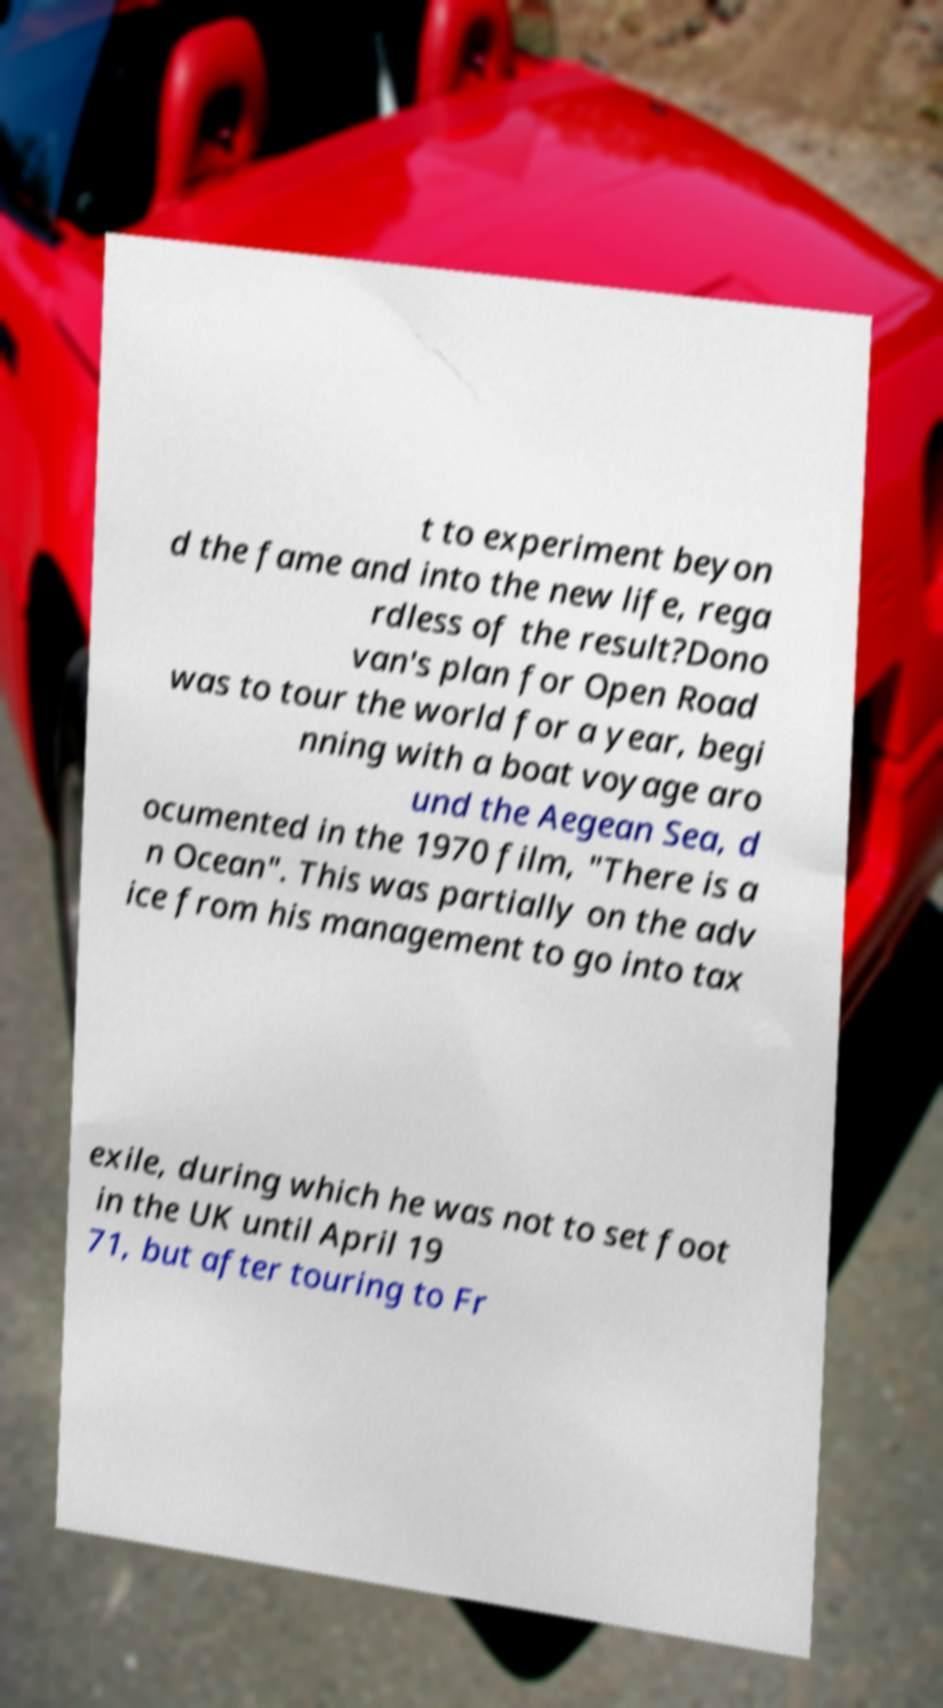Please read and relay the text visible in this image. What does it say? t to experiment beyon d the fame and into the new life, rega rdless of the result?Dono van's plan for Open Road was to tour the world for a year, begi nning with a boat voyage aro und the Aegean Sea, d ocumented in the 1970 film, "There is a n Ocean". This was partially on the adv ice from his management to go into tax exile, during which he was not to set foot in the UK until April 19 71, but after touring to Fr 